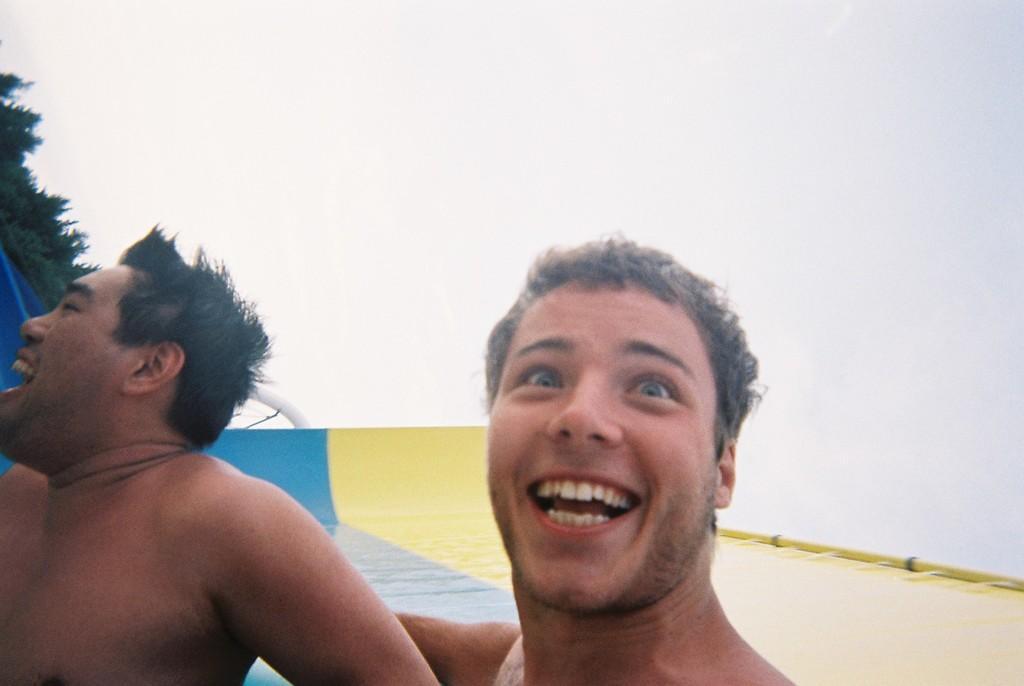How would you summarize this image in a sentence or two? In this picture I can see two men are smiling. In the background I can see sky and on the left side I can see tree. 